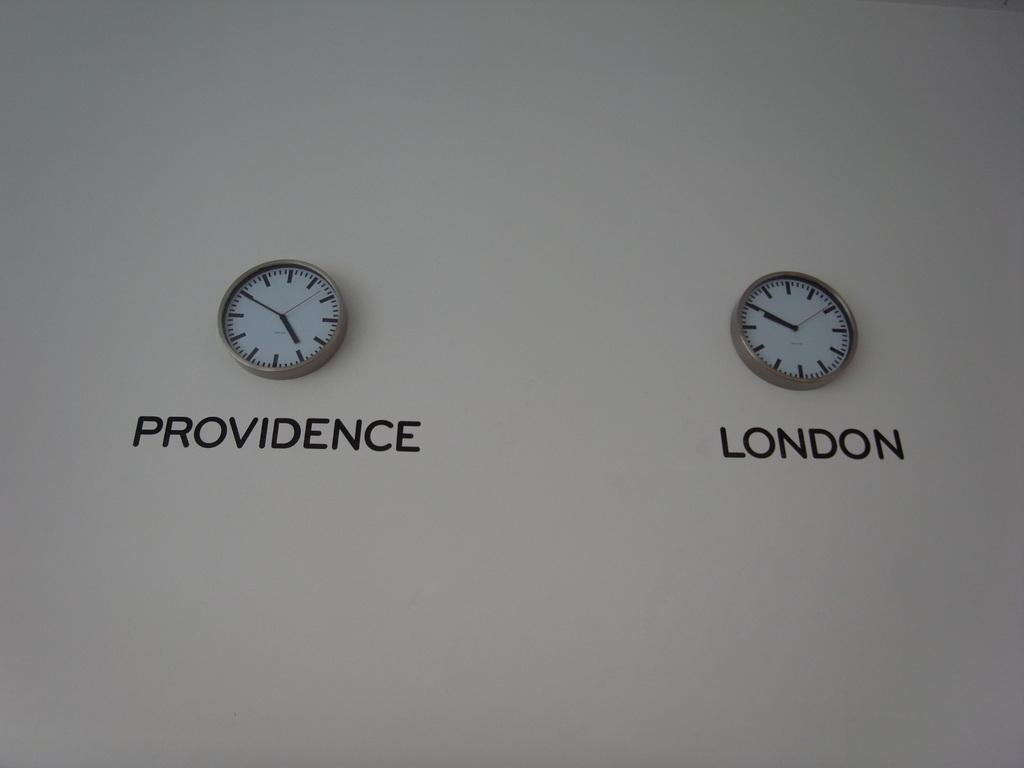Please provide a concise description of this image. In this image, there are two clocks on the wall. In these two clocks, one of them is showing providence time and another one is showing London time. 